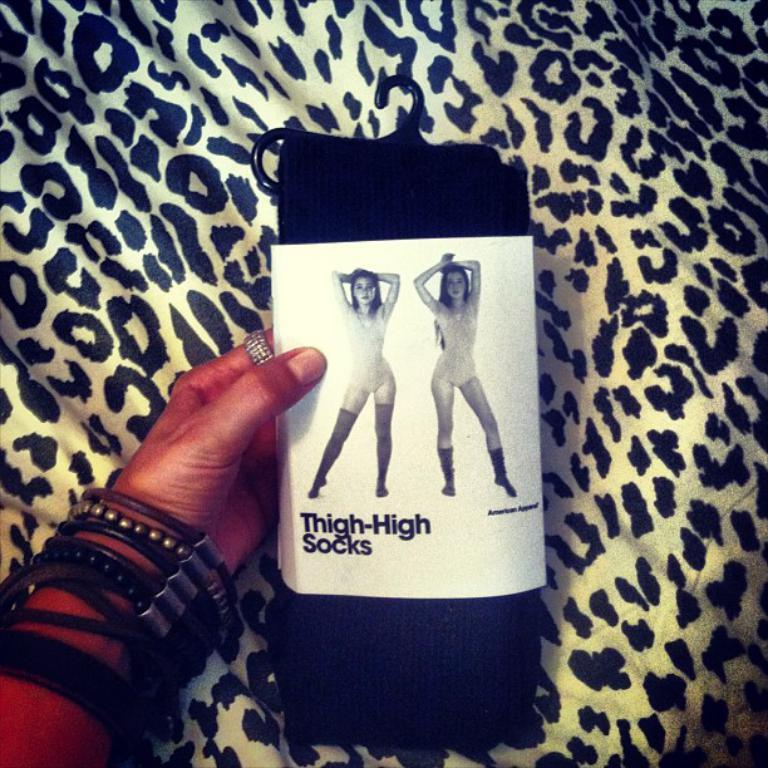What is the main subject in the center of the image? There are socks in the center of the image. Can you describe any other elements in the image? A person's hand is visible in the image. What type of bells can be heard ringing in the image? There are no bells present in the image, and therefore no sound can be heard. 